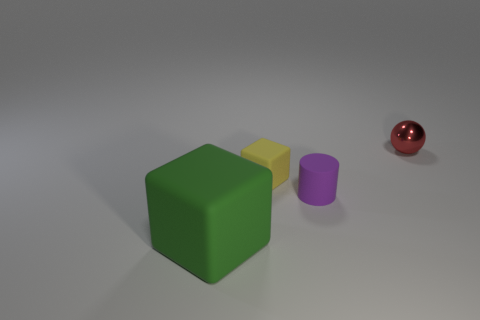Add 1 big gray balls. How many objects exist? 5 Subtract all green cubes. How many cubes are left? 1 Subtract all cylinders. How many objects are left? 3 Subtract all blue cubes. Subtract all yellow cylinders. How many cubes are left? 2 Subtract all yellow balls. How many gray cylinders are left? 0 Subtract all big red rubber balls. Subtract all large objects. How many objects are left? 3 Add 4 tiny yellow rubber cubes. How many tiny yellow rubber cubes are left? 5 Add 2 large green blocks. How many large green blocks exist? 3 Subtract 0 yellow spheres. How many objects are left? 4 